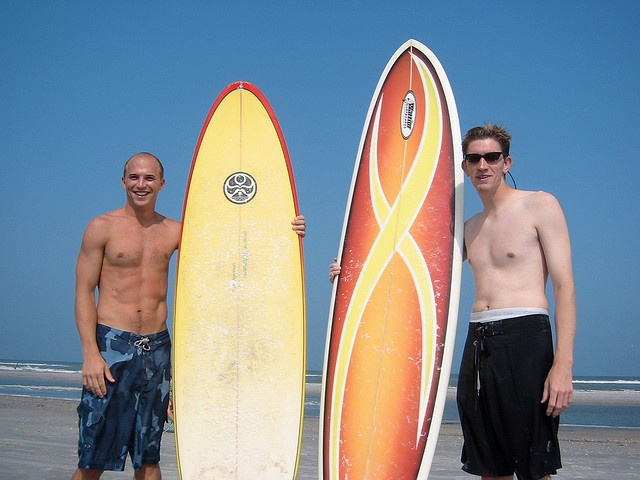Describe the objects in this image and their specific colors. I can see surfboard in teal, orange, ivory, salmon, and khaki tones, surfboard in teal, khaki, beige, and red tones, people in teal, black, lightpink, darkgray, and gray tones, people in teal, salmon, black, and navy tones, and people in teal, gray, black, and darkblue tones in this image. 